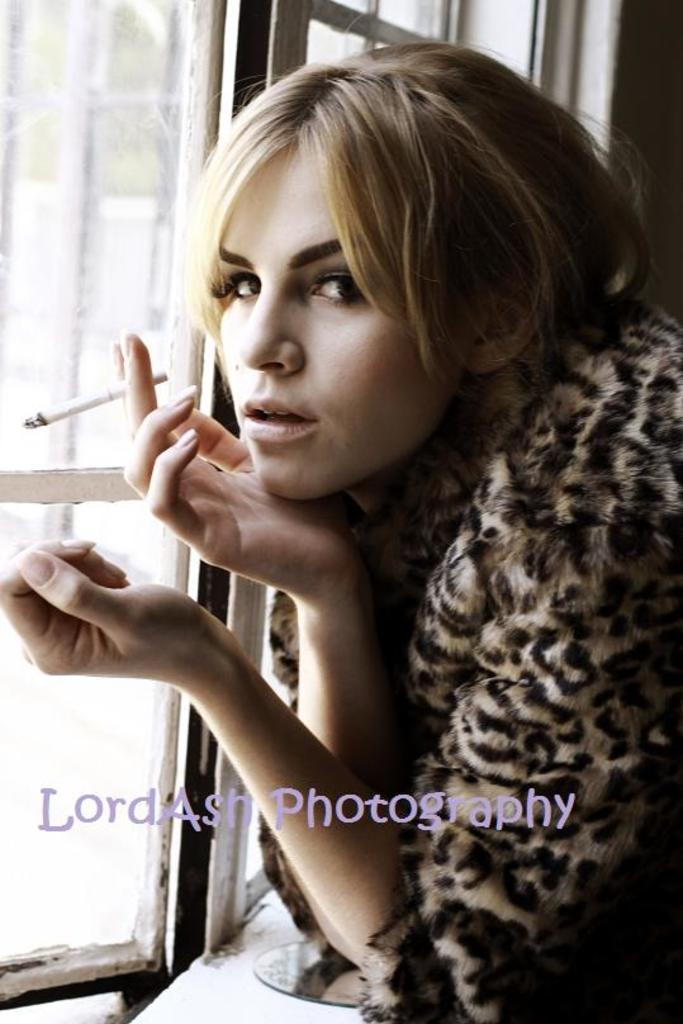Who is the main subject in the image? There is a lady in the center of the image. What is the lady holding in her hand? The lady is holding a cigarette in her hand. What can be seen on the left side of the image? There is a window on the left side of the image. What type of ray is swimming in the background of the image? There is no ray present in the image; it features a lady holding a cigarette and a window on the left side. 